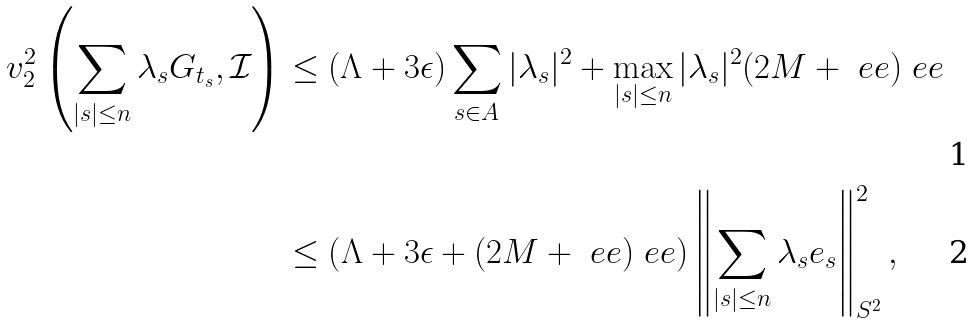<formula> <loc_0><loc_0><loc_500><loc_500>v _ { 2 } ^ { 2 } \left ( \sum _ { | s | \leq n } \lambda _ { s } G _ { t _ { s } } , \mathcal { I } \right ) & \leq ( \Lambda + 3 \epsilon ) \sum _ { s \in A } | \lambda _ { s } | ^ { 2 } + \max _ { | s | \leq n } | \lambda _ { s } | ^ { 2 } ( 2 M + \ e e ) \ e e \\ & \leq \left ( \Lambda + 3 \epsilon + ( 2 M + \ e e ) \ e e \right ) \left \| \sum _ { | s | \leq n } \lambda _ { s } e _ { s } \right \| ^ { 2 } _ { S ^ { 2 } } ,</formula> 